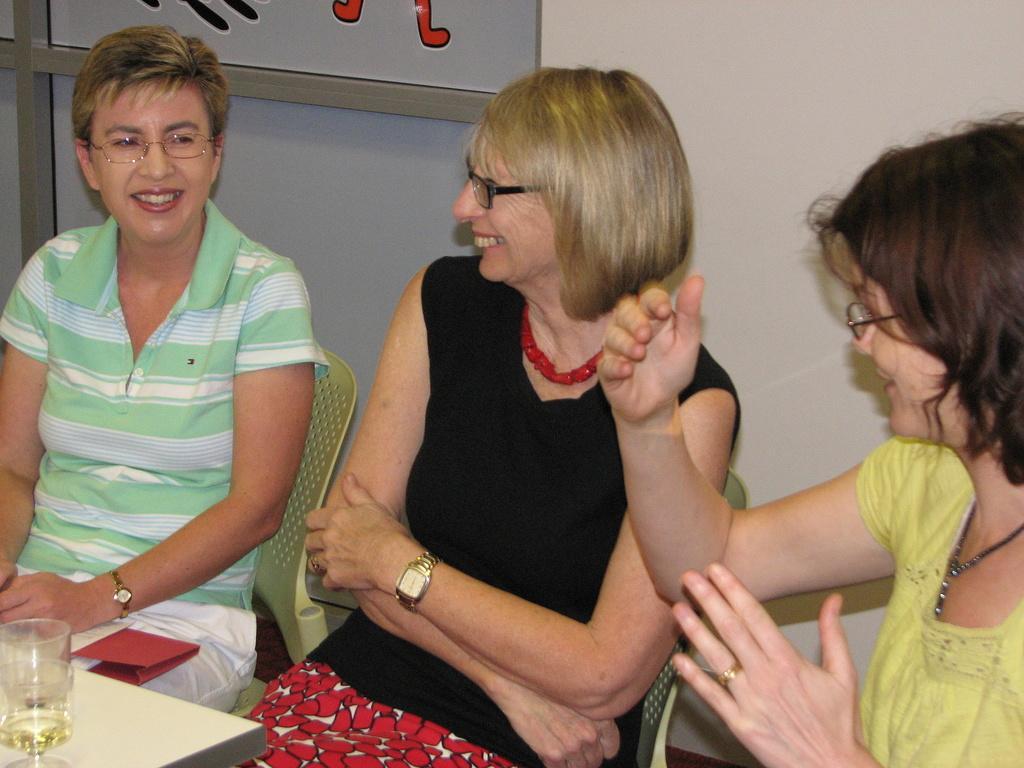Describe this image in one or two sentences. In this image there are people sitting and smiling. At the bottom there is a table and we can see a glass placed on the table. In the background there is a wall and a board. 